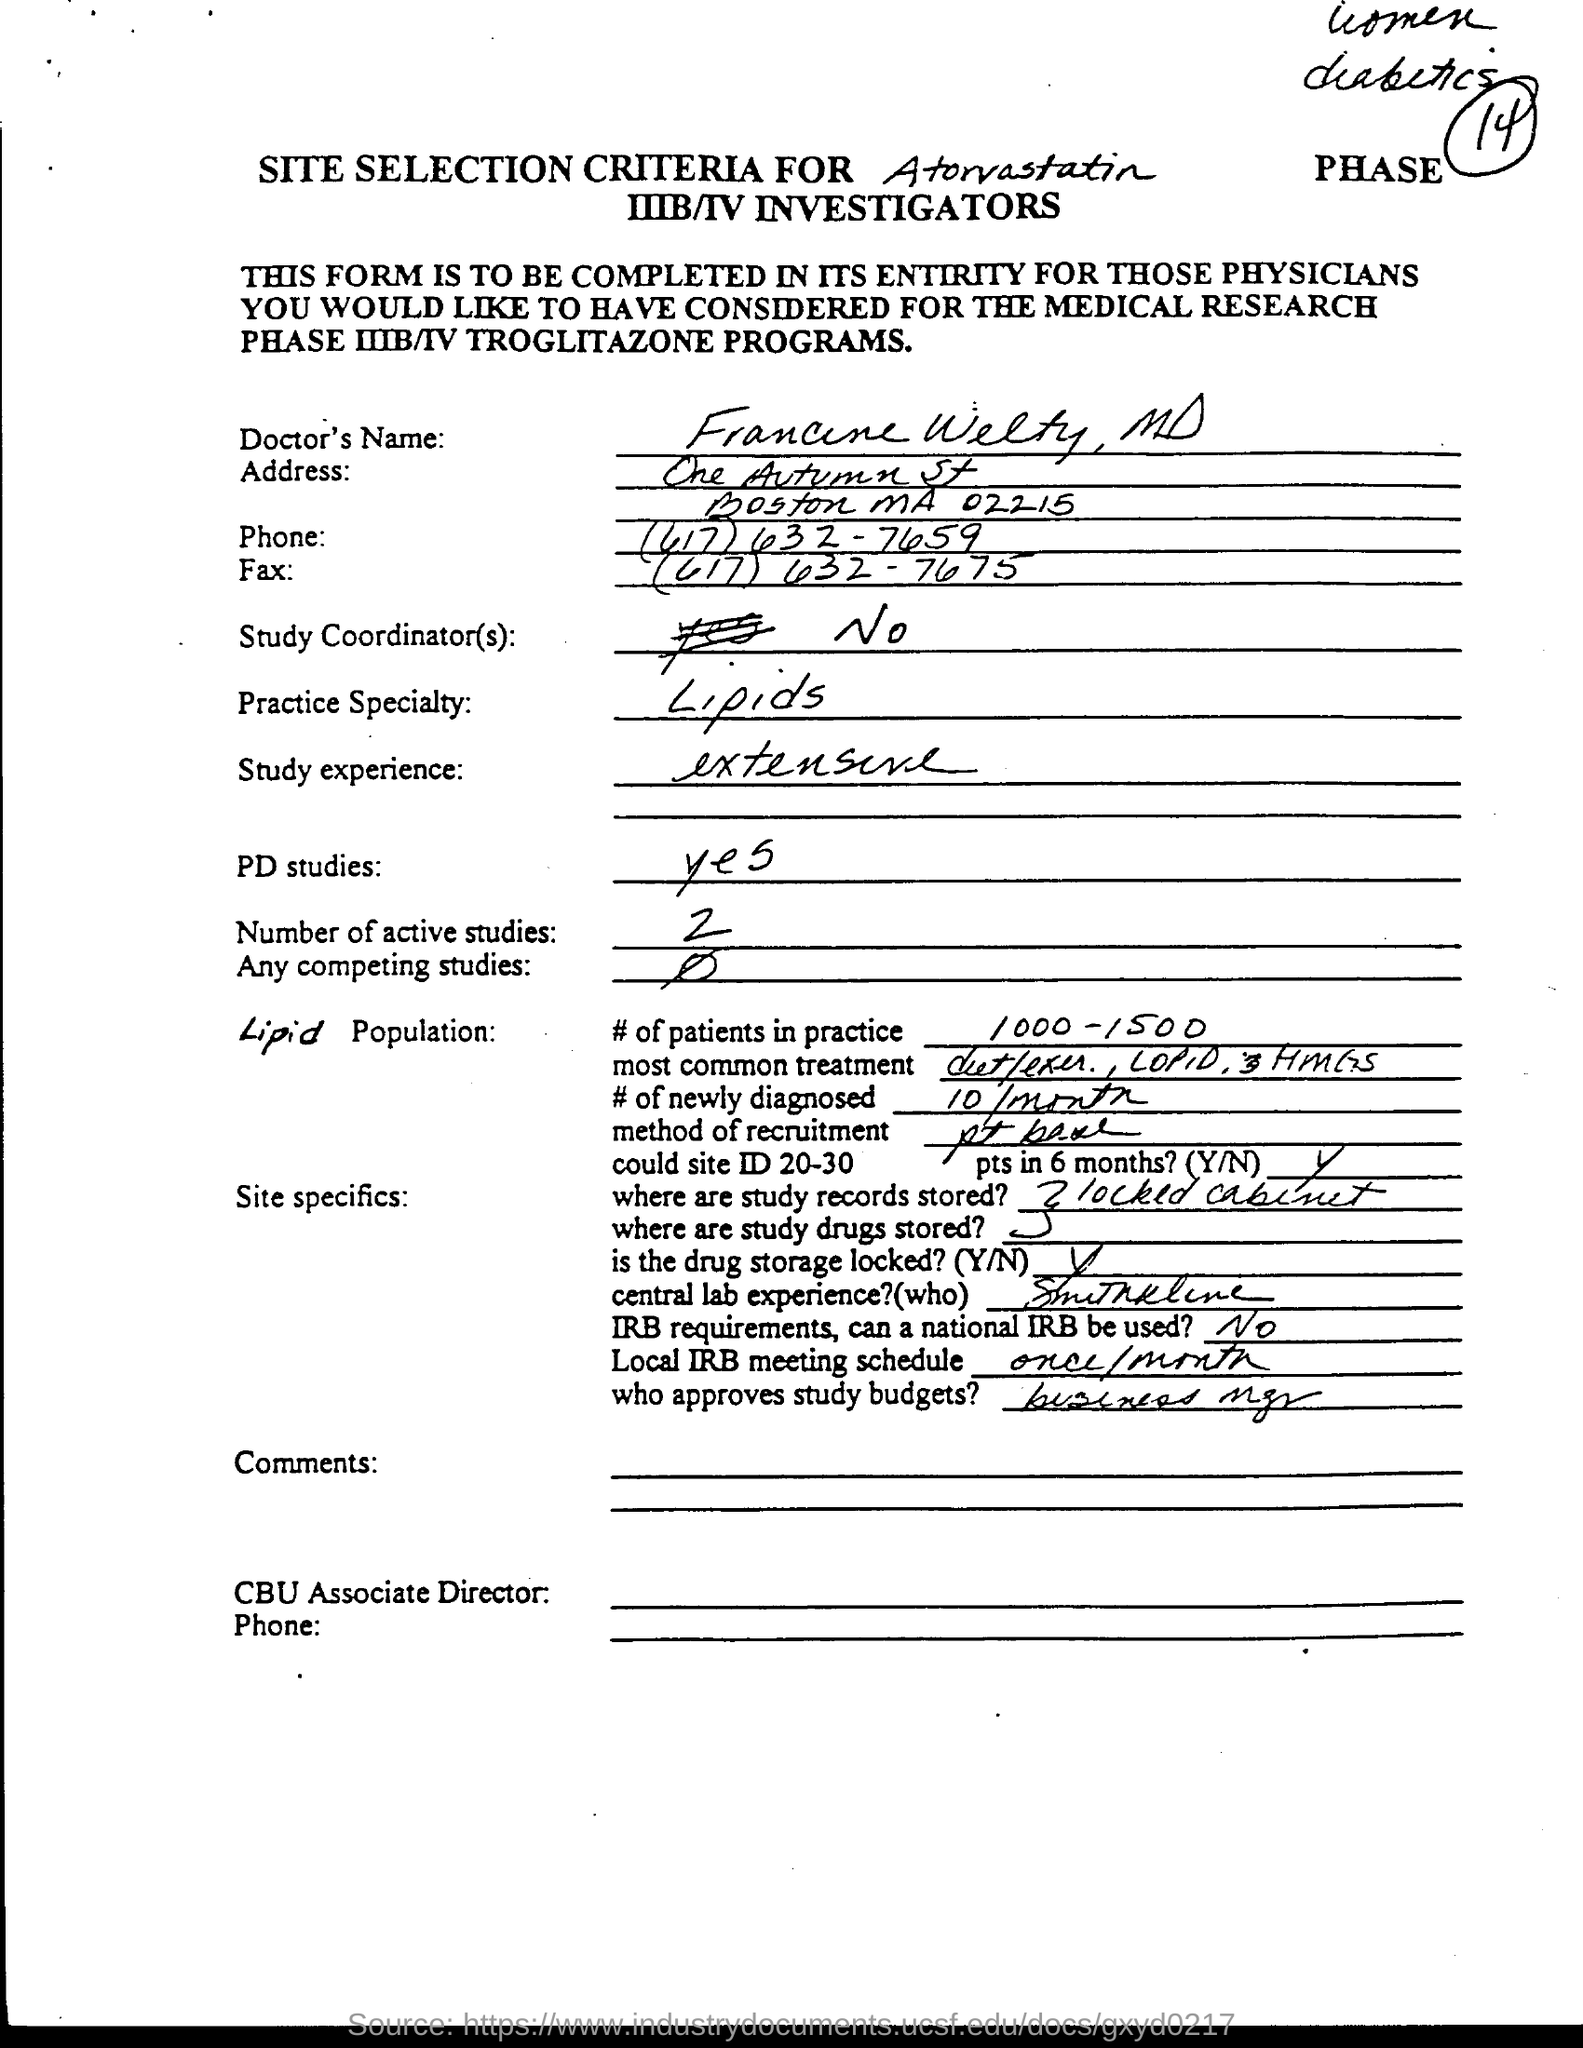What is the Doctor's Name?
Your answer should be very brief. Francine Welty. What is the Practice speciality?
Your answer should be very brief. Lipids. What is the study experience?
Keep it short and to the point. Extensive. What are the number of Active studies?
Provide a succinct answer. 2. What are the # of patients in practice?
Give a very brief answer. 1000-1500. What is the # of newly diagnosed?
Your answer should be compact. 10/month. What is the local IRB meeting schedule?
Give a very brief answer. Once/month. 